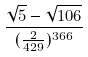<formula> <loc_0><loc_0><loc_500><loc_500>\frac { \sqrt { 5 } - \sqrt { 1 0 6 } } { ( \frac { 2 } { 4 2 9 } ) ^ { 3 6 6 } }</formula> 